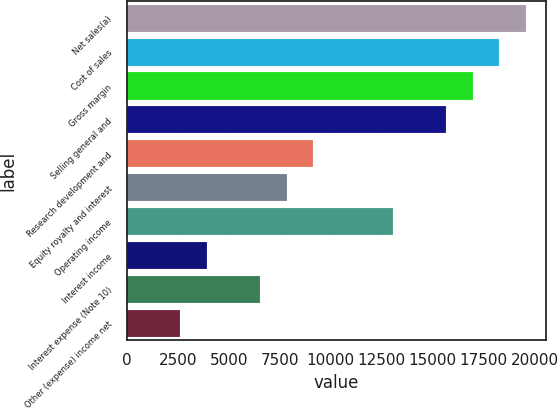Convert chart. <chart><loc_0><loc_0><loc_500><loc_500><bar_chart><fcel>Net sales(a)<fcel>Cost of sales<fcel>Gross margin<fcel>Selling general and<fcel>Research development and<fcel>Equity royalty and interest<fcel>Operating income<fcel>Interest income<fcel>Interest expense (Note 10)<fcel>Other (expense) income net<nl><fcel>19570.2<fcel>18265.7<fcel>16961.3<fcel>15656.9<fcel>9134.71<fcel>7830.28<fcel>13048<fcel>3916.99<fcel>6525.85<fcel>2612.56<nl></chart> 